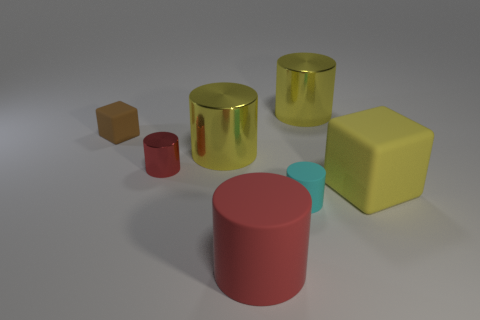What number of red rubber cylinders are there?
Make the answer very short. 1. Is the material of the small brown thing the same as the thing that is in front of the tiny cyan matte cylinder?
Offer a very short reply. Yes. Does the rubber thing that is in front of the cyan rubber cylinder have the same color as the small metallic cylinder?
Make the answer very short. Yes. What material is the cylinder that is both to the left of the red matte thing and right of the red shiny object?
Your response must be concise. Metal. The yellow matte cube has what size?
Ensure brevity in your answer.  Large. Does the big matte cylinder have the same color as the cube behind the yellow cube?
Give a very brief answer. No. What number of other things are there of the same color as the tiny rubber cylinder?
Provide a succinct answer. 0. Does the cube on the right side of the big red cylinder have the same size as the red cylinder that is to the right of the red metal thing?
Your response must be concise. Yes. What color is the big metallic cylinder behind the tiny brown block?
Your response must be concise. Yellow. Are there fewer large matte things to the left of the large red rubber object than things?
Your answer should be compact. Yes. 